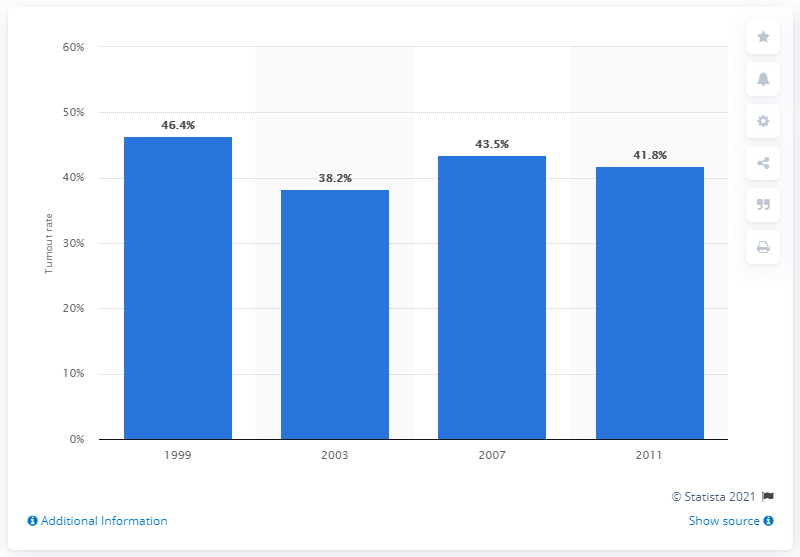List a handful of essential elements in this visual. The lowest turnout rate occurred in 2003. 